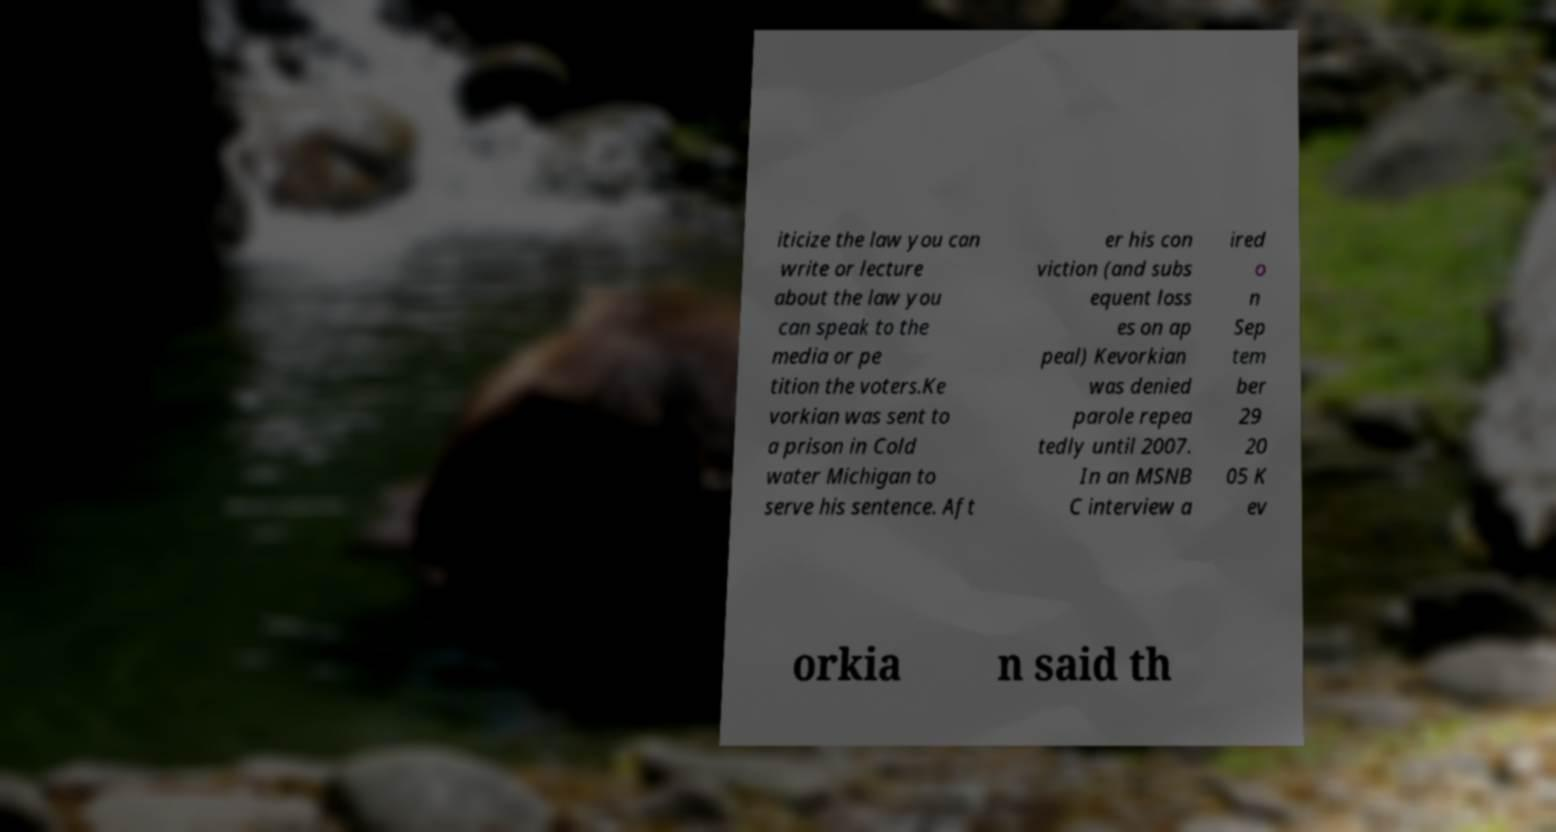Can you accurately transcribe the text from the provided image for me? iticize the law you can write or lecture about the law you can speak to the media or pe tition the voters.Ke vorkian was sent to a prison in Cold water Michigan to serve his sentence. Aft er his con viction (and subs equent loss es on ap peal) Kevorkian was denied parole repea tedly until 2007. In an MSNB C interview a ired o n Sep tem ber 29 20 05 K ev orkia n said th 